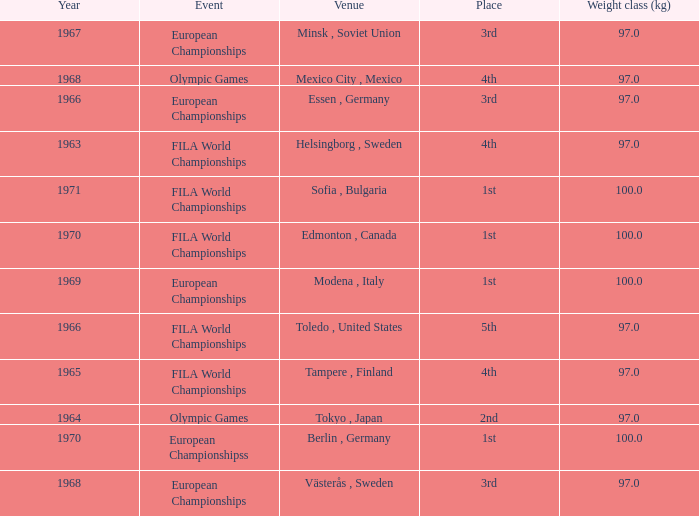What is the lowest weight class (kg) that has sofia, bulgaria as the venue? 100.0. 